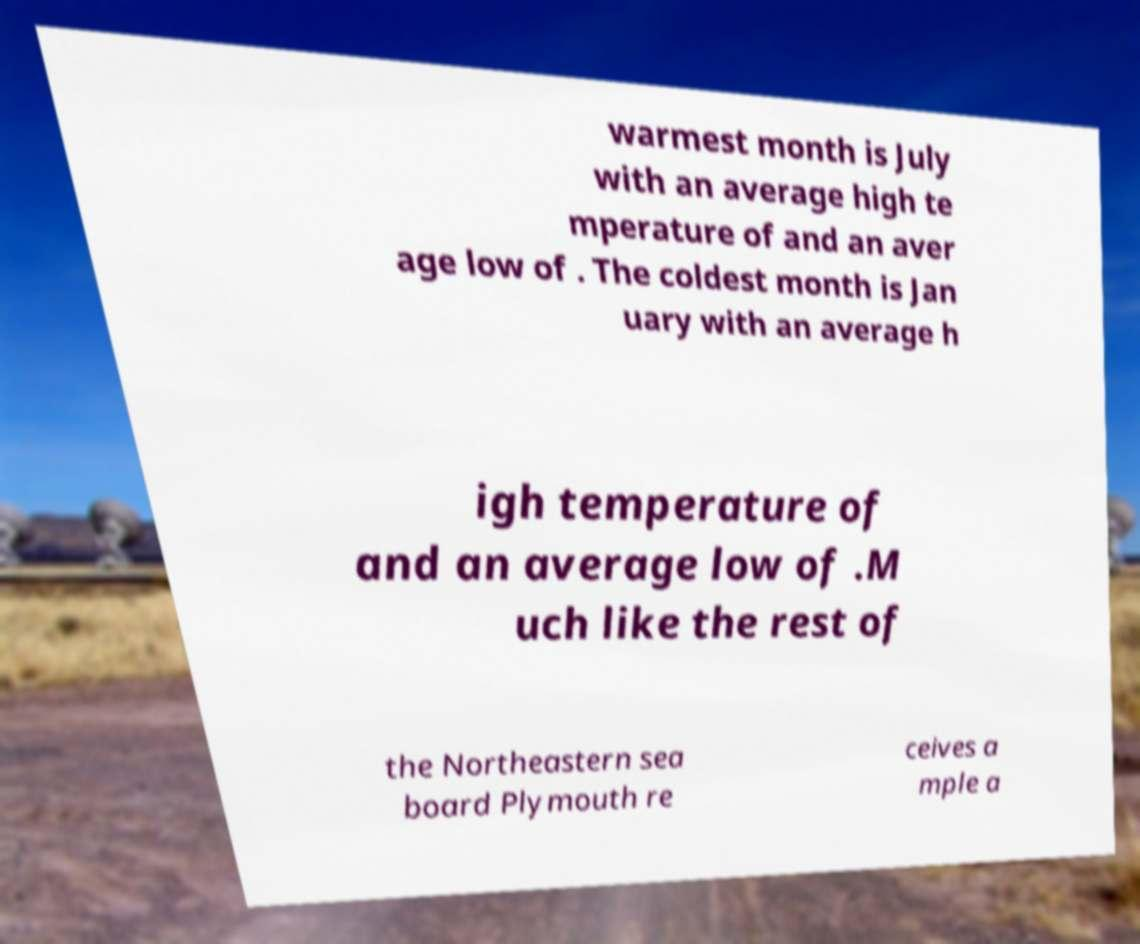Can you accurately transcribe the text from the provided image for me? warmest month is July with an average high te mperature of and an aver age low of . The coldest month is Jan uary with an average h igh temperature of and an average low of .M uch like the rest of the Northeastern sea board Plymouth re ceives a mple a 